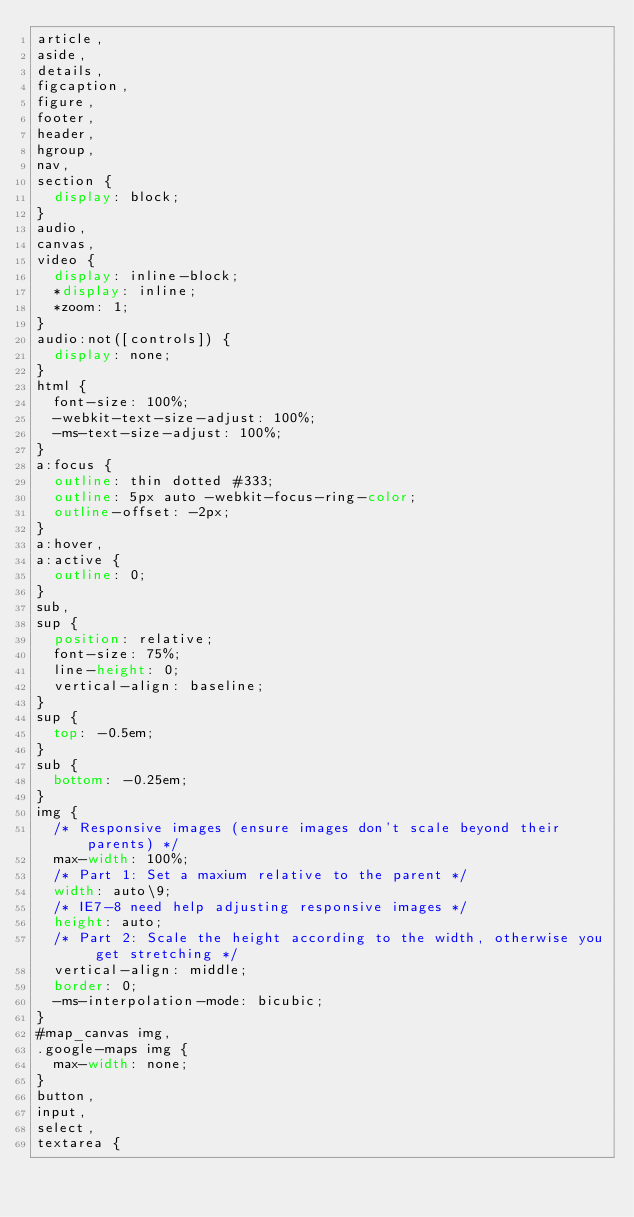Convert code to text. <code><loc_0><loc_0><loc_500><loc_500><_CSS_>article,
aside,
details,
figcaption,
figure,
footer,
header,
hgroup,
nav,
section {
  display: block;
}
audio,
canvas,
video {
  display: inline-block;
  *display: inline;
  *zoom: 1;
}
audio:not([controls]) {
  display: none;
}
html {
  font-size: 100%;
  -webkit-text-size-adjust: 100%;
  -ms-text-size-adjust: 100%;
}
a:focus {
  outline: thin dotted #333;
  outline: 5px auto -webkit-focus-ring-color;
  outline-offset: -2px;
}
a:hover,
a:active {
  outline: 0;
}
sub,
sup {
  position: relative;
  font-size: 75%;
  line-height: 0;
  vertical-align: baseline;
}
sup {
  top: -0.5em;
}
sub {
  bottom: -0.25em;
}
img {
  /* Responsive images (ensure images don't scale beyond their parents) */
  max-width: 100%;
  /* Part 1: Set a maxium relative to the parent */
  width: auto\9;
  /* IE7-8 need help adjusting responsive images */
  height: auto;
  /* Part 2: Scale the height according to the width, otherwise you get stretching */
  vertical-align: middle;
  border: 0;
  -ms-interpolation-mode: bicubic;
}
#map_canvas img,
.google-maps img {
  max-width: none;
}
button,
input,
select,
textarea {</code> 